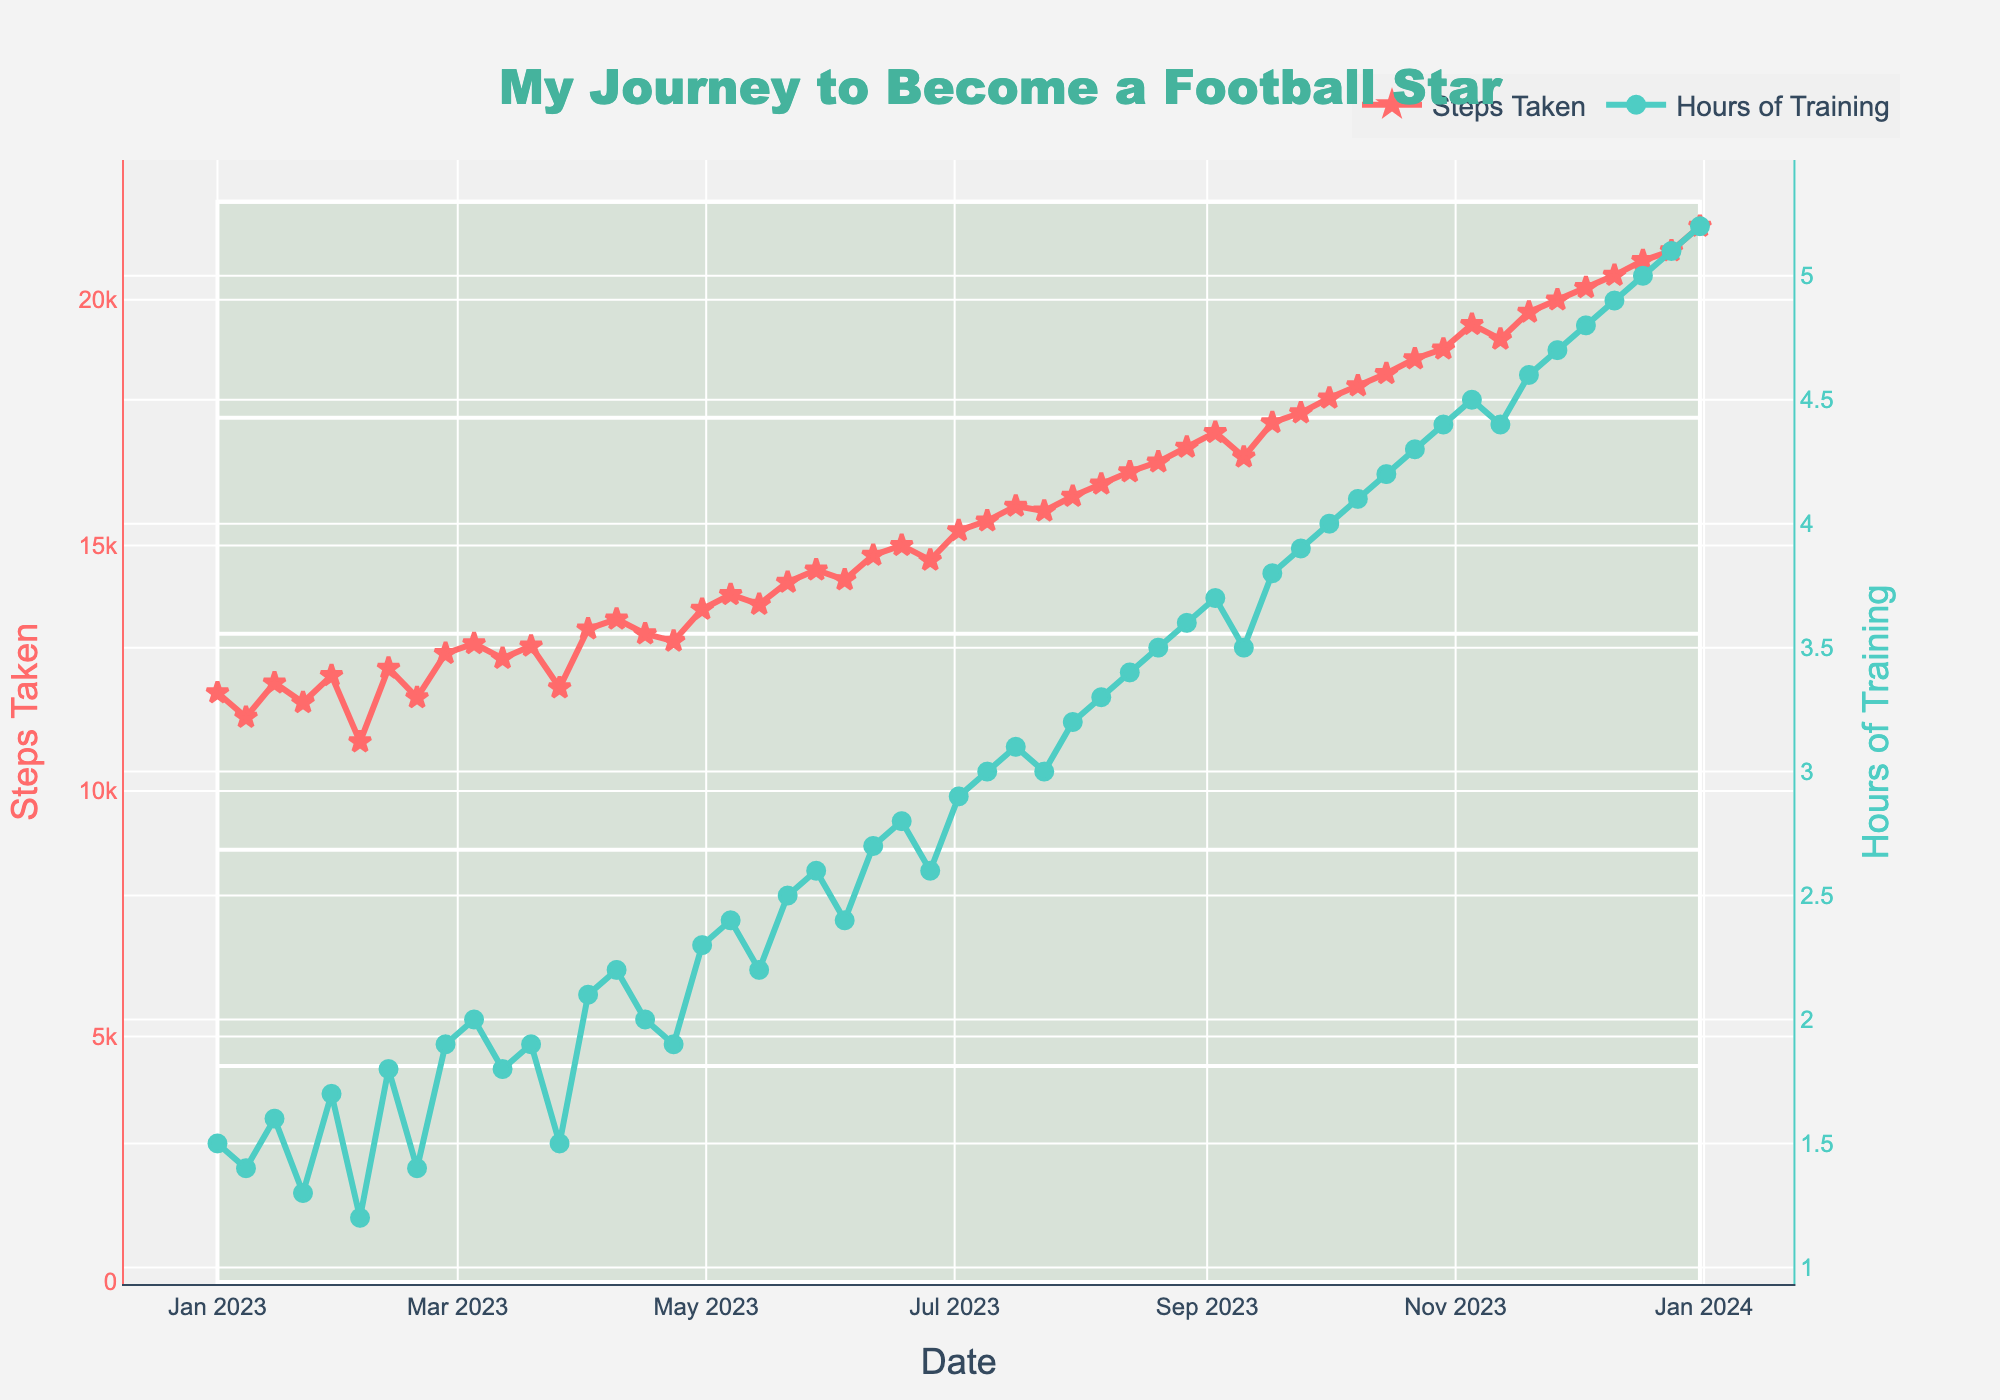How many data points are there for "Steps Taken"? Count the number of points along the "Steps Taken" line. There should be one data point for each week of the year, thus 52 data points in total
Answer: 52 What's the average number of "Hours of Training" in October 2023? To find the average, first sum the hours of training for October: 4.0 + 4.1 + 4.2 + 4.3 + 4.4 = 21.0. Then divide by the number of weeks: 21.0 / 5 = 4.2
Answer: 4.2 Which metric shows a larger increase over the year, "Steps Taken" or "Hours of Training"? "Steps Taken" starts at 12000 in January and ends at 21500 in December, an increase of 9500 steps. "Hours of Training" starts at 1.5 hours in January and ends at 5.2 hours in December, an increase of 3.7 hours. Thus, "Steps Taken" shows a larger numerical increase compared to "Hours of Training"
Answer: Steps Taken During which month did "Hours of Training" first reach 3 hours? Locate the first data point where "Hours of Training" is 3 hours or more. This occurs in July 2023
Answer: July 2023 How do the trends of "Steps Taken" and "Hours of Training" compare from January to December? Observe the figure and note that both metrics show a general upward trend throughout the year. "Steps Taken" increases steadily, starting from 12000 steps in January to 21500 in December. "Hours of Training" also increases over time from 1.5 hours in January to 5.2 hours by December
Answer: Both metrics trend upward What is the difference in "Steps Taken" between the highest and lowest weeks? The highest "Steps Taken" is 21500 in December. The lowest is 11000 in February. Therefore, the difference is 21500 - 11000 = 10500
Answer: 10500 In which month is the maximum "Steps Taken"? Identify the highest point on the "Steps Taken" line, which occurs near the end of the year in December
Answer: December 2023 What is the ratio of "Hours of Training" to "Steps Taken" for the last week of the year? For the last week of December 2023, "Steps Taken" is 21500 and "Hours of Training" is 5.2. The ratio is thus 5.2 / 21500 = 0.000242
Answer: 0.000242 